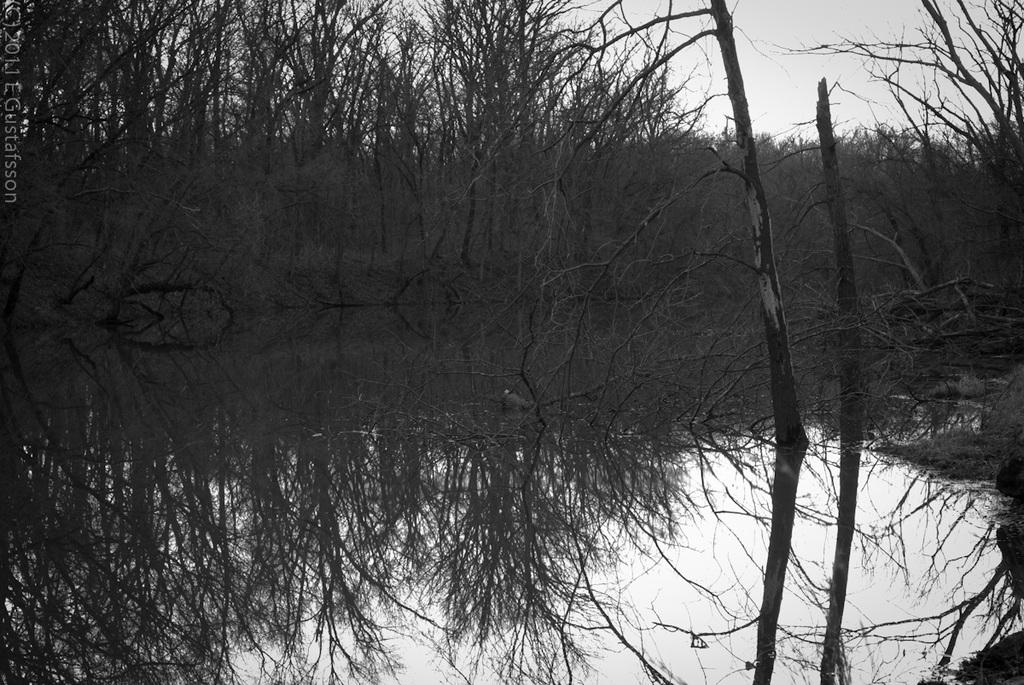What is one of the main elements in the image? There is water in the image. What else can be seen in the image besides water? There are trees in the image, and the reflection of trees is visible in the water. What is visible in the background of the image? The sky is visible in the image. Is there any text present in the image? Yes, there is some text in the top left corner of the image. What direction is the tree growing in the image? There is no specific tree mentioned in the image, and the direction of growth cannot be determined from the provided facts. 